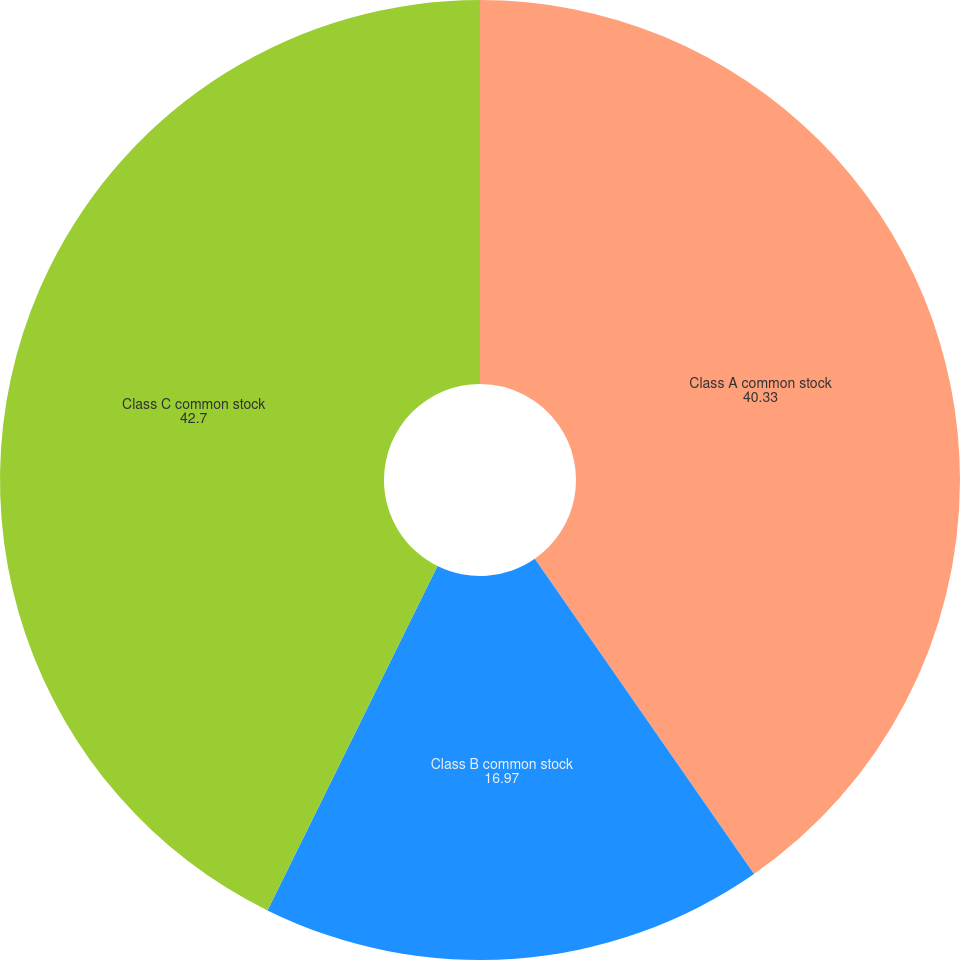<chart> <loc_0><loc_0><loc_500><loc_500><pie_chart><fcel>Class A common stock<fcel>Class B common stock<fcel>Class C common stock<nl><fcel>40.33%<fcel>16.97%<fcel>42.7%<nl></chart> 